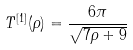<formula> <loc_0><loc_0><loc_500><loc_500>T ^ { [ 1 ] } ( \rho ) = \frac { 6 \pi } { \sqrt { 7 \rho + 9 } }</formula> 